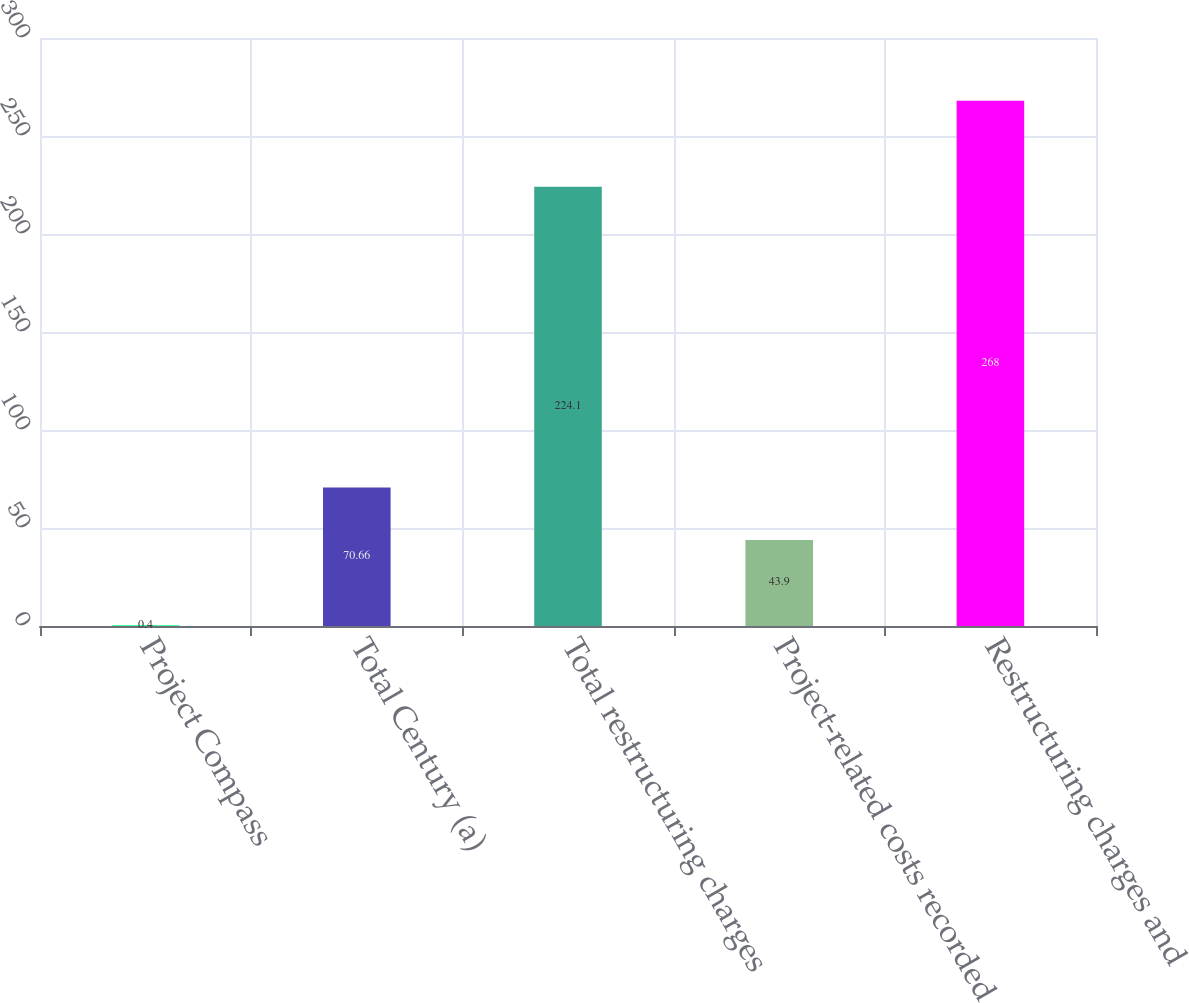Convert chart to OTSL. <chart><loc_0><loc_0><loc_500><loc_500><bar_chart><fcel>Project Compass<fcel>Total Century (a)<fcel>Total restructuring charges<fcel>Project-related costs recorded<fcel>Restructuring charges and<nl><fcel>0.4<fcel>70.66<fcel>224.1<fcel>43.9<fcel>268<nl></chart> 